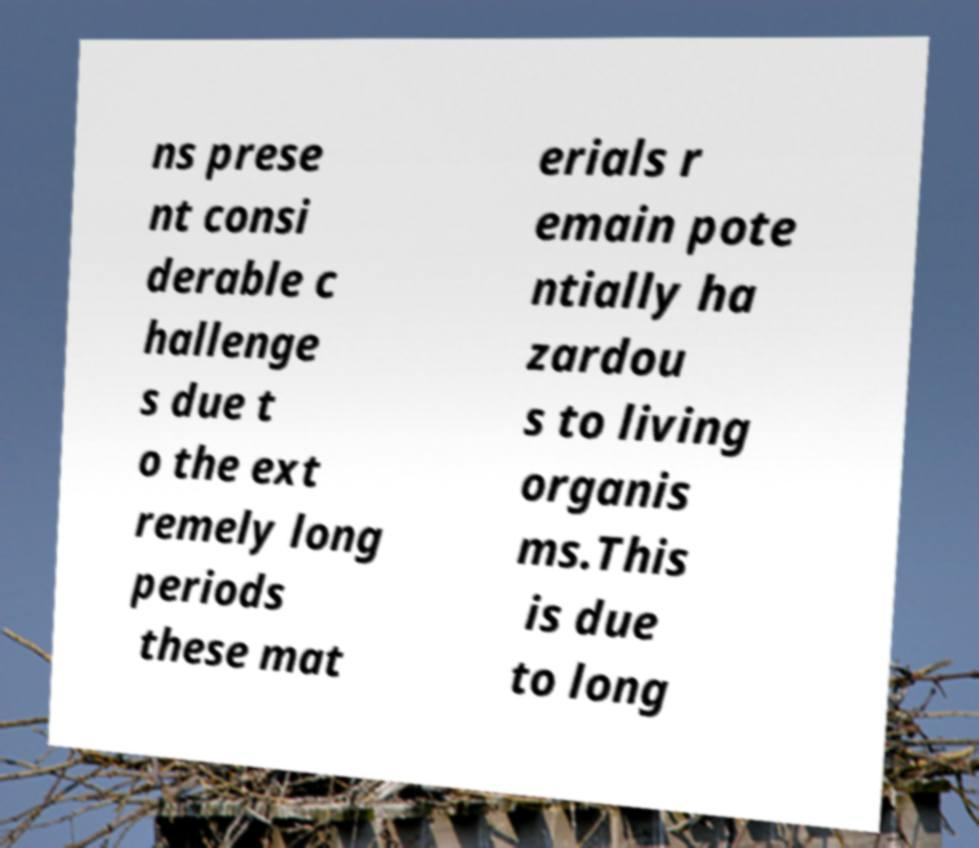There's text embedded in this image that I need extracted. Can you transcribe it verbatim? ns prese nt consi derable c hallenge s due t o the ext remely long periods these mat erials r emain pote ntially ha zardou s to living organis ms.This is due to long 